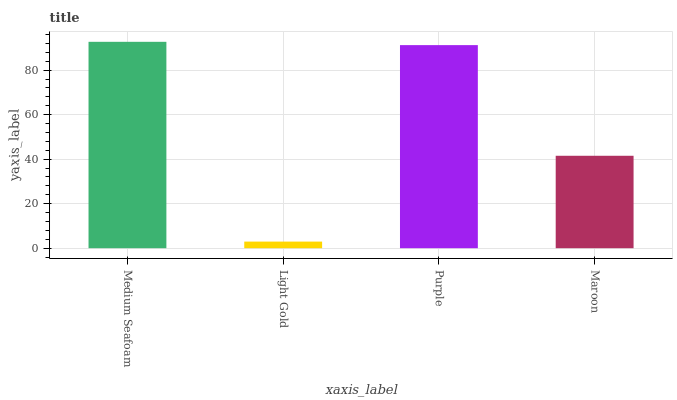Is Light Gold the minimum?
Answer yes or no. Yes. Is Medium Seafoam the maximum?
Answer yes or no. Yes. Is Purple the minimum?
Answer yes or no. No. Is Purple the maximum?
Answer yes or no. No. Is Purple greater than Light Gold?
Answer yes or no. Yes. Is Light Gold less than Purple?
Answer yes or no. Yes. Is Light Gold greater than Purple?
Answer yes or no. No. Is Purple less than Light Gold?
Answer yes or no. No. Is Purple the high median?
Answer yes or no. Yes. Is Maroon the low median?
Answer yes or no. Yes. Is Maroon the high median?
Answer yes or no. No. Is Purple the low median?
Answer yes or no. No. 